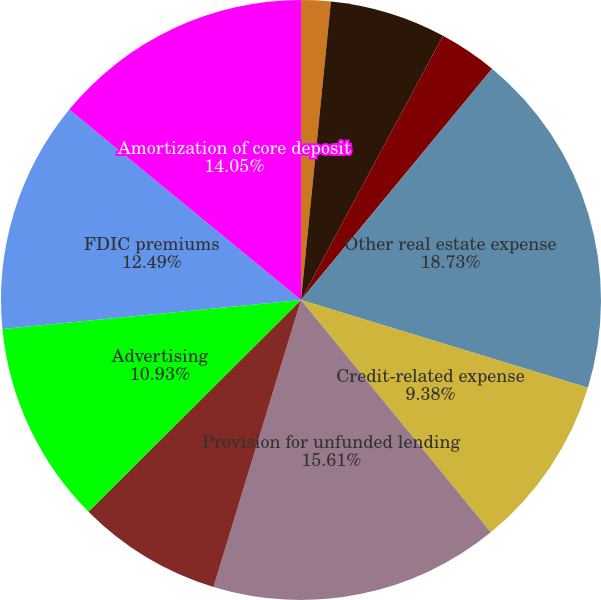Convert chart to OTSL. <chart><loc_0><loc_0><loc_500><loc_500><pie_chart><fcel>Salaries and employee benefits<fcel>Occupancy net<fcel>Furniture equipment and<fcel>Other real estate expense<fcel>Credit-related expense<fcel>Provision for unfunded lending<fcel>Professional and legal<fcel>Advertising<fcel>FDIC premiums<fcel>Amortization of core deposit<nl><fcel>1.59%<fcel>6.26%<fcel>3.14%<fcel>18.73%<fcel>9.38%<fcel>15.61%<fcel>7.82%<fcel>10.93%<fcel>12.49%<fcel>14.05%<nl></chart> 